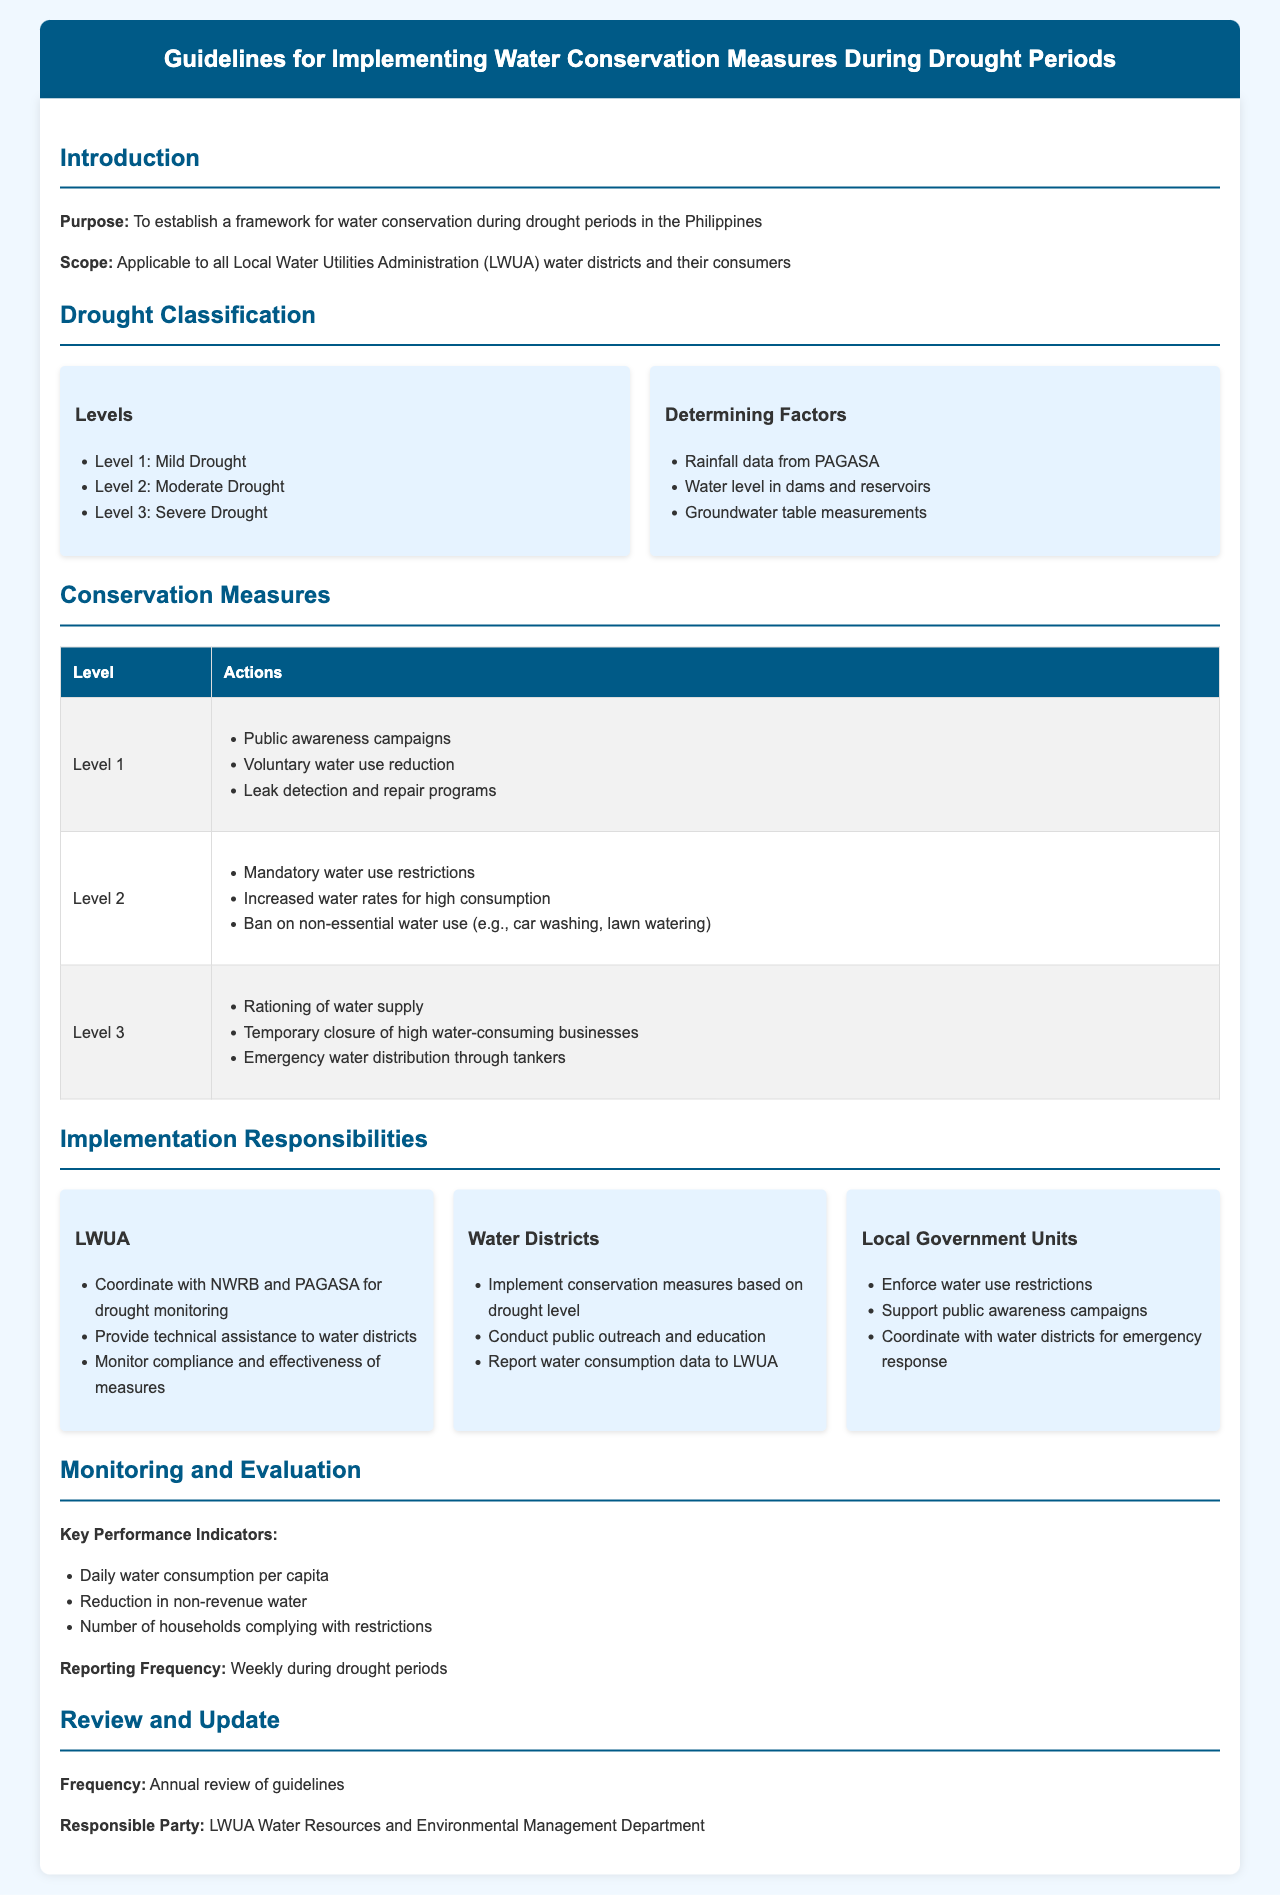what is the purpose of the document? The purpose is established in the introduction section and specifies the intention to create a framework for water conservation during drought periods in the Philippines.
Answer: to establish a framework for water conservation during drought periods in the Philippines how many levels of drought classification are mentioned? The document lists three levels of drought classification under the Drought Classification section.
Answer: three what actions are required at Level 2 of drought? The conservation measures table specifies mandatory water use restrictions, increased water rates for high consumption, and a ban on non-essential water use.
Answer: mandatory water use restrictions, increased water rates for high consumption, ban on non-essential water use who is responsible for monitoring compliance with water conservation measures? The Implementation Responsibilities section indicates that the LWUA is responsible for monitoring compliance and effectiveness of measures.
Answer: LWUA what is the reporting frequency during drought periods? The Monitoring and Evaluation section states the reporting frequency clearly as weekly during drought periods.
Answer: weekly 